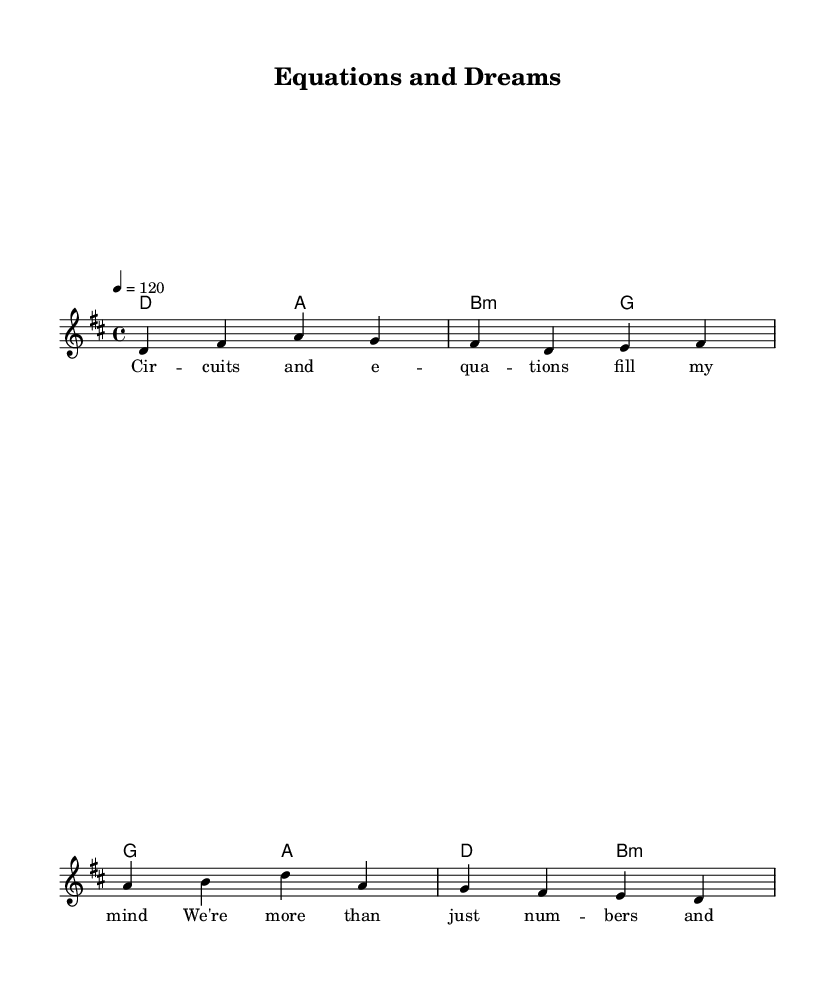What is the key signature of this music? The key signature is D major, indicated by two sharps (F# and C#) in the key signature line.
Answer: D major What is the time signature of the piece? The time signature is 4/4, which means there are four beats in each measure and a quarter note receives one beat, as stated at the beginning of the score.
Answer: 4/4 What is the tempo marking for this piece? The tempo marking is 120, indicated in quarter note beats per minute, showing the speed at which the piece should be played.
Answer: 120 How many measures are there in the verse section? The verse section consists of two measures as indicated, which contain the melody and chord changes specifically labeled for the verse.
Answer: 2 measures What type of chord is used in the second measure of the verse? The second measure of the verse has an A major chord, indicated through the chord mode syntax.
Answer: A major What is the lyrical theme reflected in the lyrics? The lyrics refer to the challenges of student life, emphasizing concepts such as equations and the burdens of education, which captures the essence of struggle and triumph.
Answer: Student life What is the last note in the melody of the chorus? The last note in the melody of the chorus is D, which is a whole note as seen at the end of the chorus section in the score.
Answer: D 